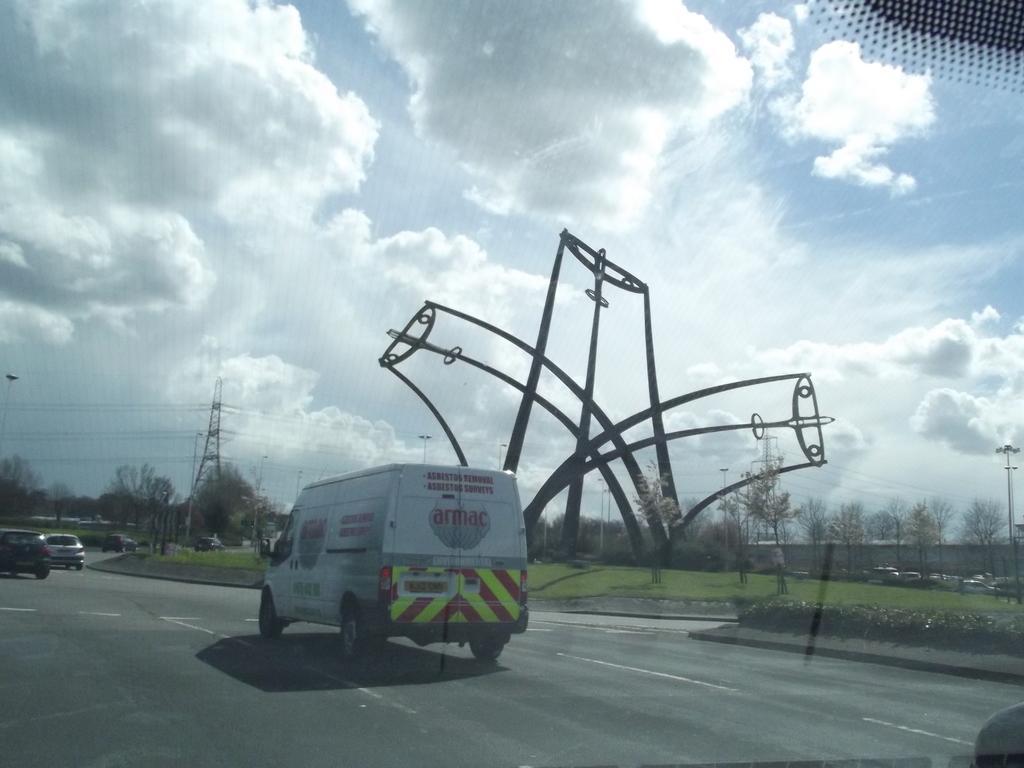Describe this image in one or two sentences. In this image I can see a vehicle which is white, red and silver in color on the road and I can see few other vehicles on the road. In the background I can see a tower, few trees, some grass, few other vehicles, the wall and the sky. 